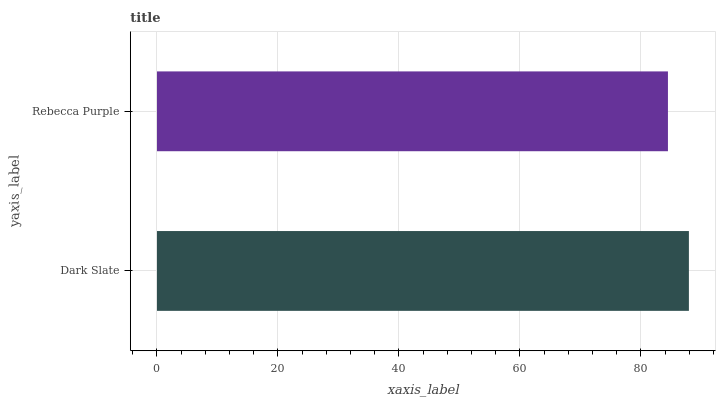Is Rebecca Purple the minimum?
Answer yes or no. Yes. Is Dark Slate the maximum?
Answer yes or no. Yes. Is Rebecca Purple the maximum?
Answer yes or no. No. Is Dark Slate greater than Rebecca Purple?
Answer yes or no. Yes. Is Rebecca Purple less than Dark Slate?
Answer yes or no. Yes. Is Rebecca Purple greater than Dark Slate?
Answer yes or no. No. Is Dark Slate less than Rebecca Purple?
Answer yes or no. No. Is Dark Slate the high median?
Answer yes or no. Yes. Is Rebecca Purple the low median?
Answer yes or no. Yes. Is Rebecca Purple the high median?
Answer yes or no. No. Is Dark Slate the low median?
Answer yes or no. No. 